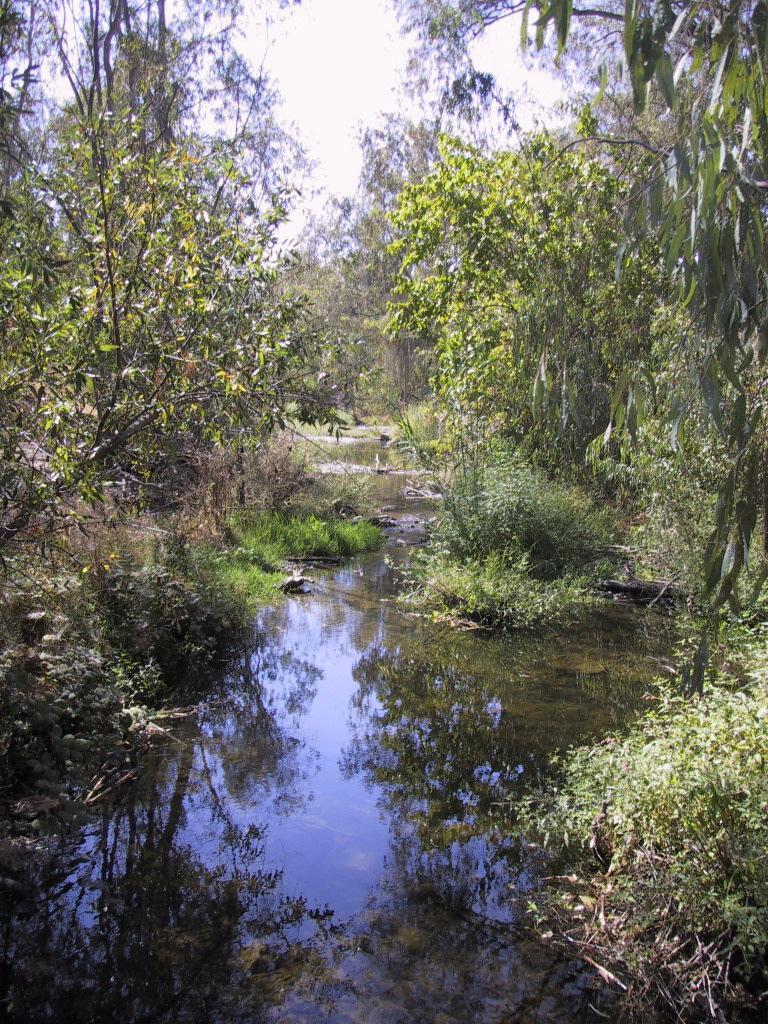In one or two sentences, can you explain what this image depicts? In the given image i can see a trees,water,plants and in the background i can see the sky. 